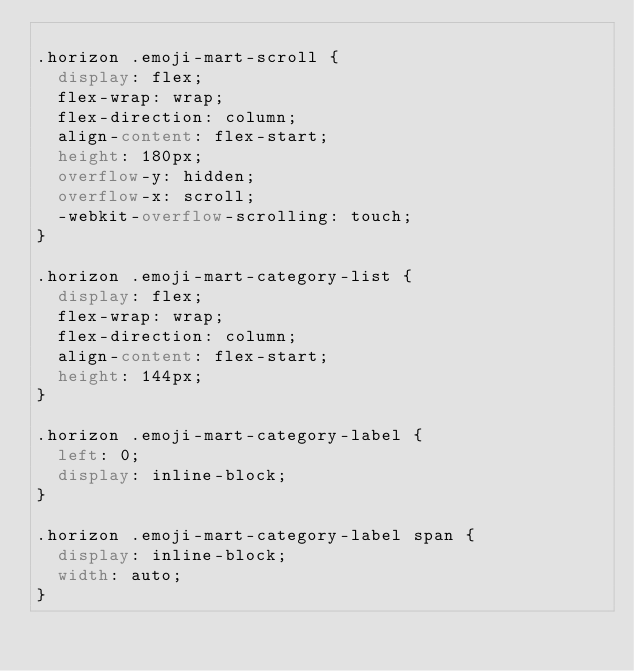<code> <loc_0><loc_0><loc_500><loc_500><_CSS_>
.horizon .emoji-mart-scroll {
  display: flex;
  flex-wrap: wrap;
  flex-direction: column;
  align-content: flex-start;
  height: 180px;
  overflow-y: hidden;
  overflow-x: scroll;
  -webkit-overflow-scrolling: touch;
}

.horizon .emoji-mart-category-list {
  display: flex;
  flex-wrap: wrap;
  flex-direction: column;
  align-content: flex-start;
  height: 144px;
}

.horizon .emoji-mart-category-label {
  left: 0;
  display: inline-block;
}

.horizon .emoji-mart-category-label span {
  display: inline-block;
  width: auto;
}</code> 